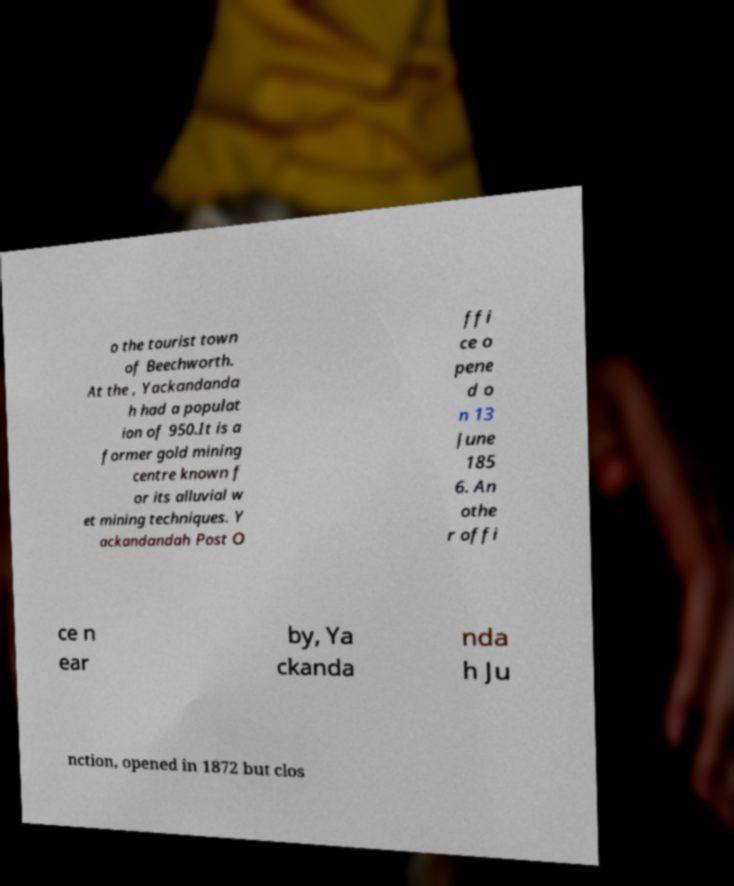Could you assist in decoding the text presented in this image and type it out clearly? o the tourist town of Beechworth. At the , Yackandanda h had a populat ion of 950.It is a former gold mining centre known f or its alluvial w et mining techniques. Y ackandandah Post O ffi ce o pene d o n 13 June 185 6. An othe r offi ce n ear by, Ya ckanda nda h Ju nction, opened in 1872 but clos 